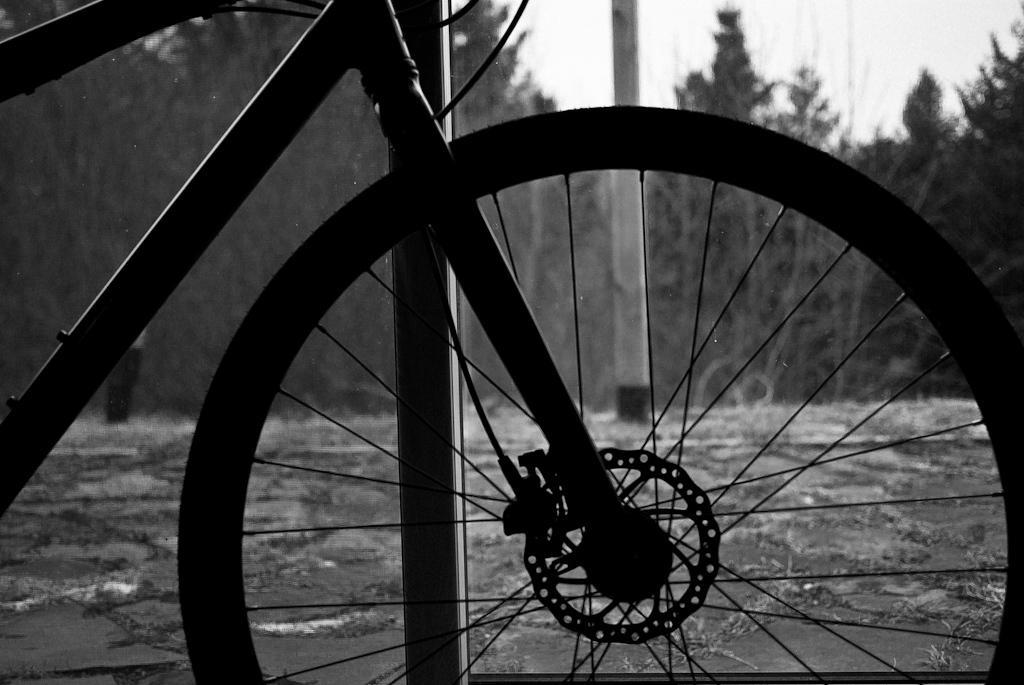In one or two sentences, can you explain what this image depicts? It's a cycle there are trees at the backside of an image. 